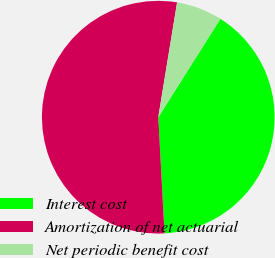Convert chart to OTSL. <chart><loc_0><loc_0><loc_500><loc_500><pie_chart><fcel>Interest cost<fcel>Amortization of net actuarial<fcel>Net periodic benefit cost<nl><fcel>40.19%<fcel>53.44%<fcel>6.37%<nl></chart> 